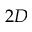<formula> <loc_0><loc_0><loc_500><loc_500>2 D</formula> 